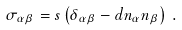<formula> <loc_0><loc_0><loc_500><loc_500>\sigma _ { \alpha \beta } = s \left ( { \delta _ { \alpha \beta } - d n _ { \alpha } n _ { \beta } } \right ) \, .</formula> 